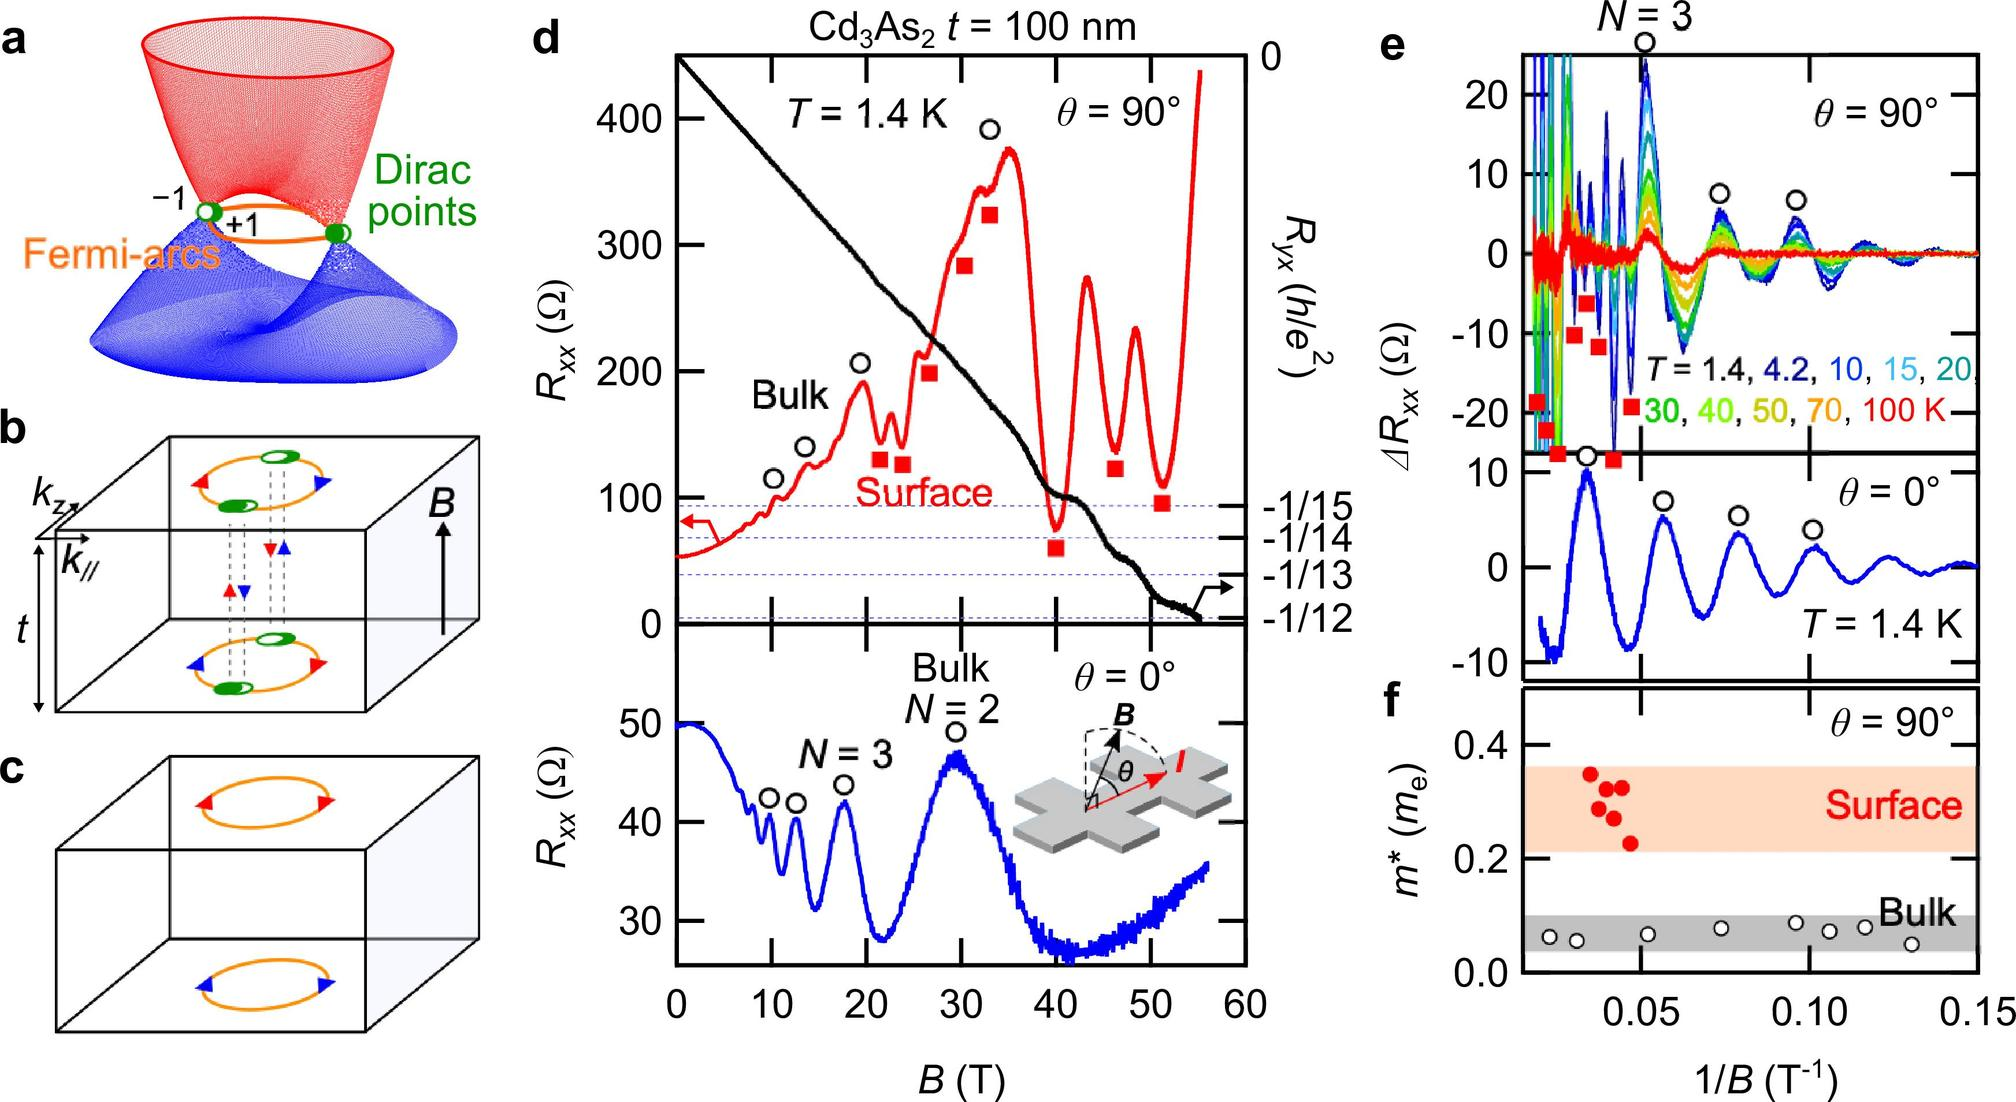What does the temperature variation (seen in panel e) tell us about the material's properties? Panel e showcases the temperature-dependent behavior of resistance (Rxx) for the material. As temperature increases (color spectrum from dark blue to red), the fluctuations in resistance become less pronounced, which likely suggests that thermal energy contributes to smearing out quantum states. This indicates that as temperature rises, the quantum effects that dominate at lower temperatures diminish, highlighting the material’s sensitive response to thermal variations, potentially useful for thermal sensors or devices operating in variable environments. 